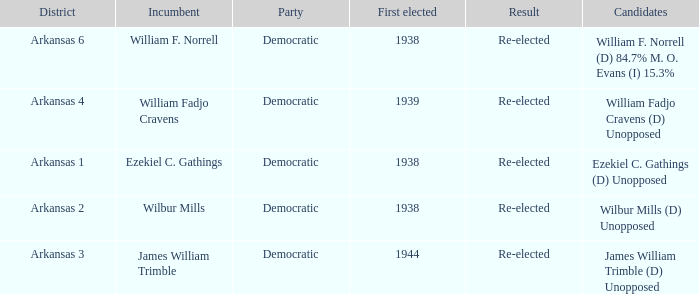How many were first elected in the Arkansas 4 district? 1.0. 